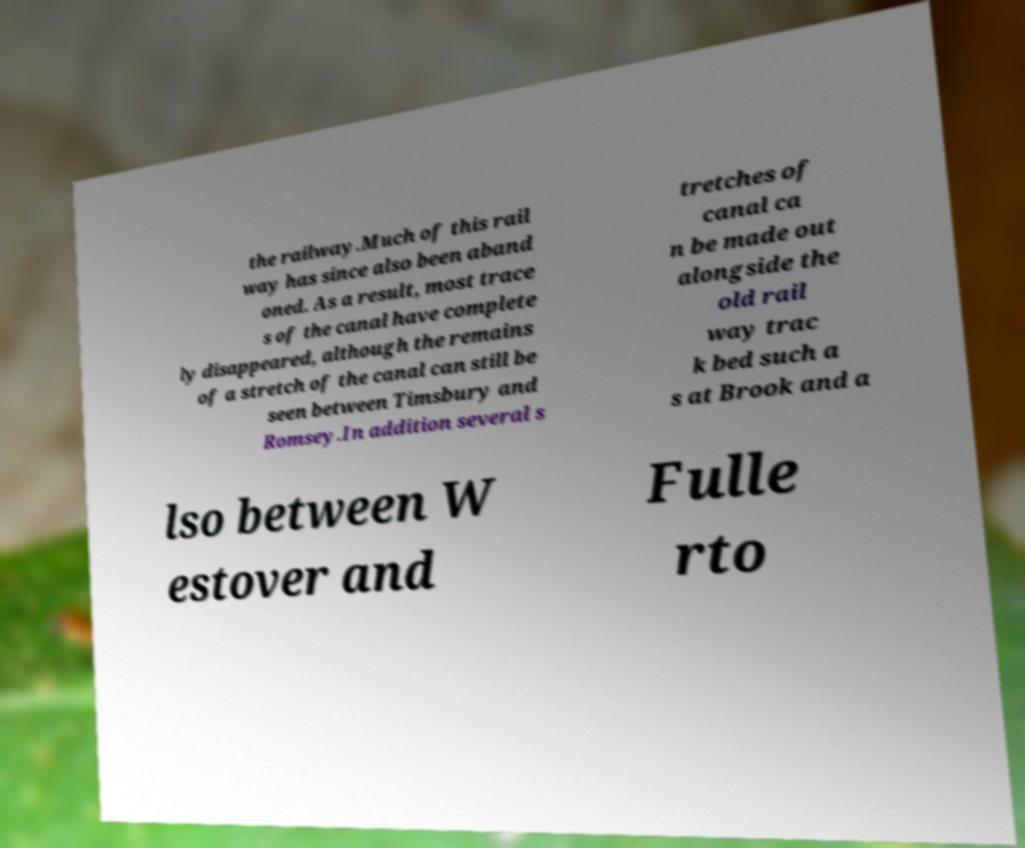Please identify and transcribe the text found in this image. the railway.Much of this rail way has since also been aband oned. As a result, most trace s of the canal have complete ly disappeared, although the remains of a stretch of the canal can still be seen between Timsbury and Romsey.In addition several s tretches of canal ca n be made out alongside the old rail way trac k bed such a s at Brook and a lso between W estover and Fulle rto 